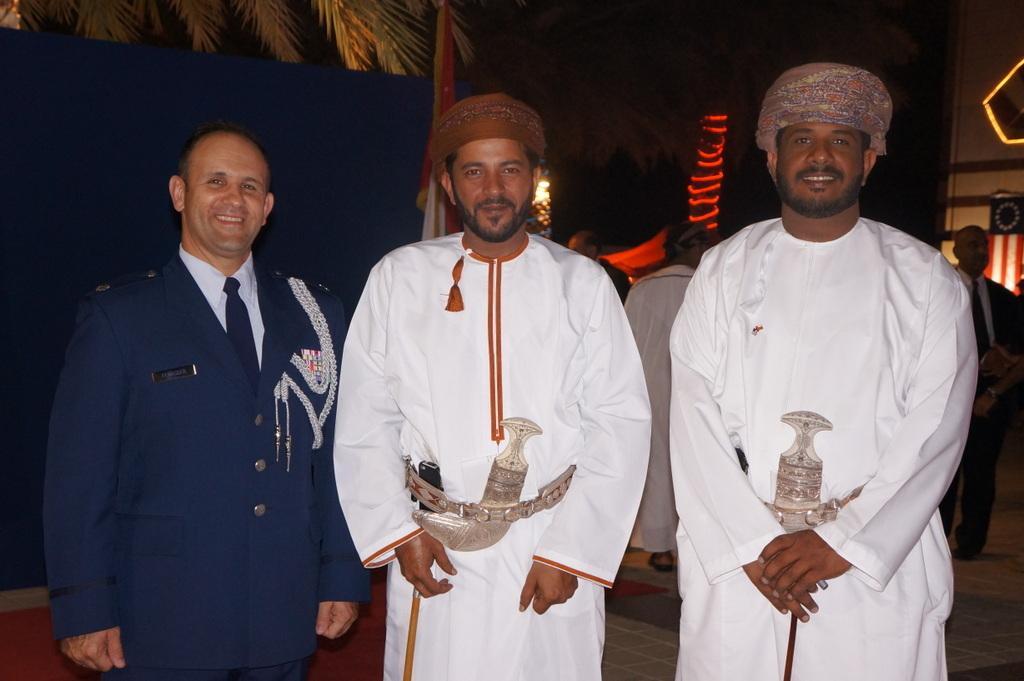Please provide a concise description of this image. In this picture we can observe three men standing. Two of them are wearing white color dress and the other man is wearing blue color coat. All of them are smiling. In the background we can observe some people. On the left side there is a tree. In the background we can observe red color lights. 